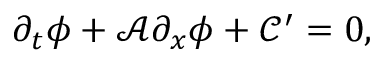Convert formula to latex. <formula><loc_0><loc_0><loc_500><loc_500>\partial _ { t } \phi + \mathcal { A } \partial _ { x } \phi + \mathcal { C } ^ { \prime } = 0 ,</formula> 